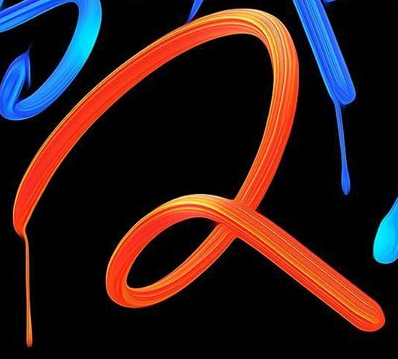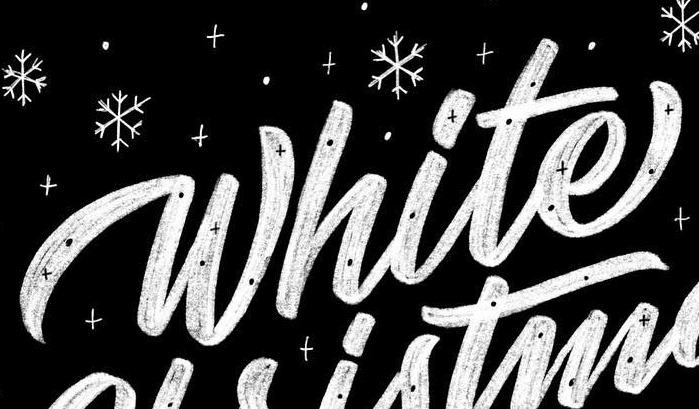Transcribe the words shown in these images in order, separated by a semicolon. 2; White 